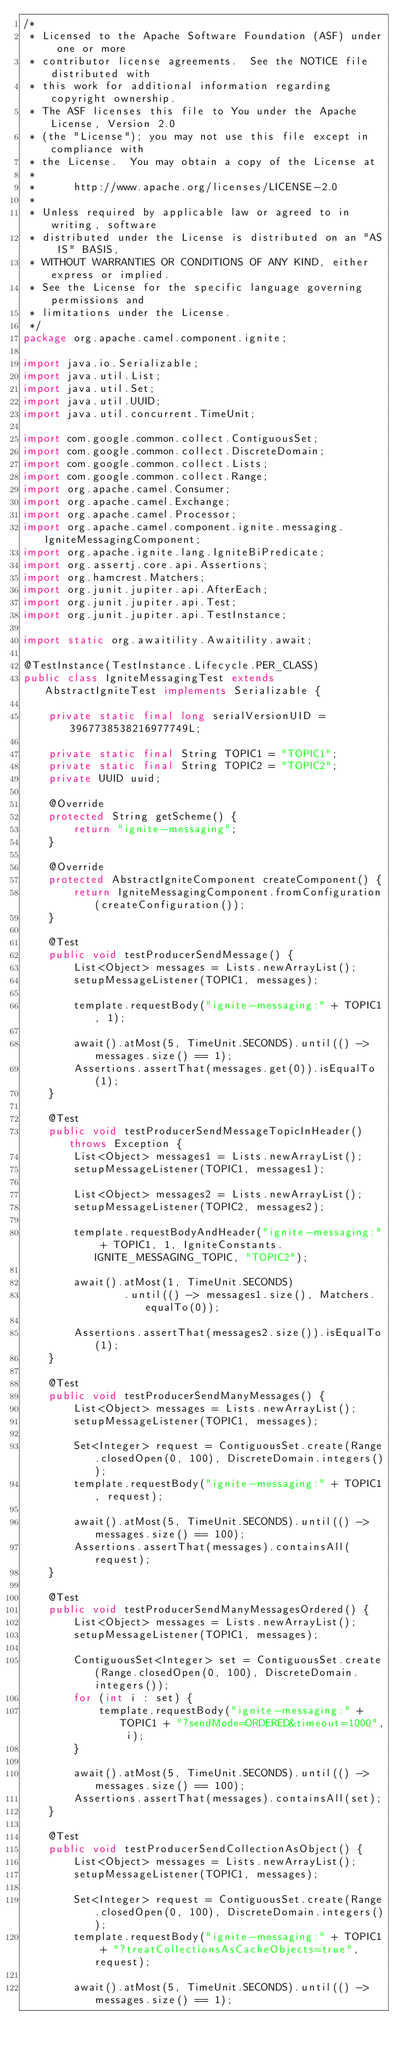Convert code to text. <code><loc_0><loc_0><loc_500><loc_500><_Java_>/*
 * Licensed to the Apache Software Foundation (ASF) under one or more
 * contributor license agreements.  See the NOTICE file distributed with
 * this work for additional information regarding copyright ownership.
 * The ASF licenses this file to You under the Apache License, Version 2.0
 * (the "License"); you may not use this file except in compliance with
 * the License.  You may obtain a copy of the License at
 *
 *      http://www.apache.org/licenses/LICENSE-2.0
 *
 * Unless required by applicable law or agreed to in writing, software
 * distributed under the License is distributed on an "AS IS" BASIS,
 * WITHOUT WARRANTIES OR CONDITIONS OF ANY KIND, either express or implied.
 * See the License for the specific language governing permissions and
 * limitations under the License.
 */
package org.apache.camel.component.ignite;

import java.io.Serializable;
import java.util.List;
import java.util.Set;
import java.util.UUID;
import java.util.concurrent.TimeUnit;

import com.google.common.collect.ContiguousSet;
import com.google.common.collect.DiscreteDomain;
import com.google.common.collect.Lists;
import com.google.common.collect.Range;
import org.apache.camel.Consumer;
import org.apache.camel.Exchange;
import org.apache.camel.Processor;
import org.apache.camel.component.ignite.messaging.IgniteMessagingComponent;
import org.apache.ignite.lang.IgniteBiPredicate;
import org.assertj.core.api.Assertions;
import org.hamcrest.Matchers;
import org.junit.jupiter.api.AfterEach;
import org.junit.jupiter.api.Test;
import org.junit.jupiter.api.TestInstance;

import static org.awaitility.Awaitility.await;

@TestInstance(TestInstance.Lifecycle.PER_CLASS)
public class IgniteMessagingTest extends AbstractIgniteTest implements Serializable {

    private static final long serialVersionUID = 3967738538216977749L;

    private static final String TOPIC1 = "TOPIC1";
    private static final String TOPIC2 = "TOPIC2";
    private UUID uuid;

    @Override
    protected String getScheme() {
        return "ignite-messaging";
    }

    @Override
    protected AbstractIgniteComponent createComponent() {
        return IgniteMessagingComponent.fromConfiguration(createConfiguration());
    }

    @Test
    public void testProducerSendMessage() {
        List<Object> messages = Lists.newArrayList();
        setupMessageListener(TOPIC1, messages);

        template.requestBody("ignite-messaging:" + TOPIC1, 1);

        await().atMost(5, TimeUnit.SECONDS).until(() -> messages.size() == 1);
        Assertions.assertThat(messages.get(0)).isEqualTo(1);
    }

    @Test
    public void testProducerSendMessageTopicInHeader() throws Exception {
        List<Object> messages1 = Lists.newArrayList();
        setupMessageListener(TOPIC1, messages1);

        List<Object> messages2 = Lists.newArrayList();
        setupMessageListener(TOPIC2, messages2);

        template.requestBodyAndHeader("ignite-messaging:" + TOPIC1, 1, IgniteConstants.IGNITE_MESSAGING_TOPIC, "TOPIC2");

        await().atMost(1, TimeUnit.SECONDS)
                .until(() -> messages1.size(), Matchers.equalTo(0));

        Assertions.assertThat(messages2.size()).isEqualTo(1);
    }

    @Test
    public void testProducerSendManyMessages() {
        List<Object> messages = Lists.newArrayList();
        setupMessageListener(TOPIC1, messages);

        Set<Integer> request = ContiguousSet.create(Range.closedOpen(0, 100), DiscreteDomain.integers());
        template.requestBody("ignite-messaging:" + TOPIC1, request);

        await().atMost(5, TimeUnit.SECONDS).until(() -> messages.size() == 100);
        Assertions.assertThat(messages).containsAll(request);
    }

    @Test
    public void testProducerSendManyMessagesOrdered() {
        List<Object> messages = Lists.newArrayList();
        setupMessageListener(TOPIC1, messages);

        ContiguousSet<Integer> set = ContiguousSet.create(Range.closedOpen(0, 100), DiscreteDomain.integers());
        for (int i : set) {
            template.requestBody("ignite-messaging:" + TOPIC1 + "?sendMode=ORDERED&timeout=1000", i);
        }

        await().atMost(5, TimeUnit.SECONDS).until(() -> messages.size() == 100);
        Assertions.assertThat(messages).containsAll(set);
    }

    @Test
    public void testProducerSendCollectionAsObject() {
        List<Object> messages = Lists.newArrayList();
        setupMessageListener(TOPIC1, messages);

        Set<Integer> request = ContiguousSet.create(Range.closedOpen(0, 100), DiscreteDomain.integers());
        template.requestBody("ignite-messaging:" + TOPIC1 + "?treatCollectionsAsCacheObjects=true", request);

        await().atMost(5, TimeUnit.SECONDS).until(() -> messages.size() == 1);</code> 